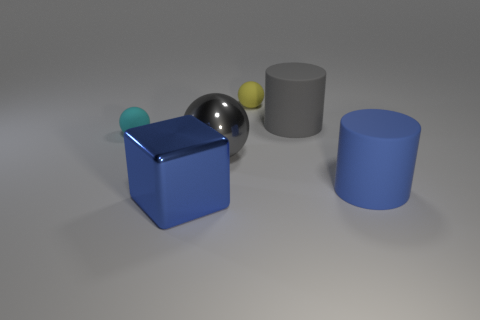How many other things are there of the same color as the metal ball?
Offer a terse response. 1. There is a object that is the same color as the shiny cube; what material is it?
Your answer should be compact. Rubber. The rubber object that is the same color as the large sphere is what size?
Your response must be concise. Large. Do the small object to the left of the big block and the metal ball have the same color?
Give a very brief answer. No. What material is the small sphere that is to the right of the large blue metallic block left of the large rubber object that is on the right side of the gray rubber object?
Keep it short and to the point. Rubber. Is there a tiny matte object of the same color as the block?
Offer a terse response. No. Are there fewer yellow things that are left of the block than large gray shiny balls?
Give a very brief answer. Yes. Do the blue cylinder right of the gray cylinder and the cyan matte thing have the same size?
Provide a succinct answer. No. What number of large objects are behind the big shiny block and in front of the cyan object?
Your answer should be very brief. 2. There is a gray thing that is behind the rubber thing that is to the left of the gray sphere; how big is it?
Your answer should be compact. Large. 